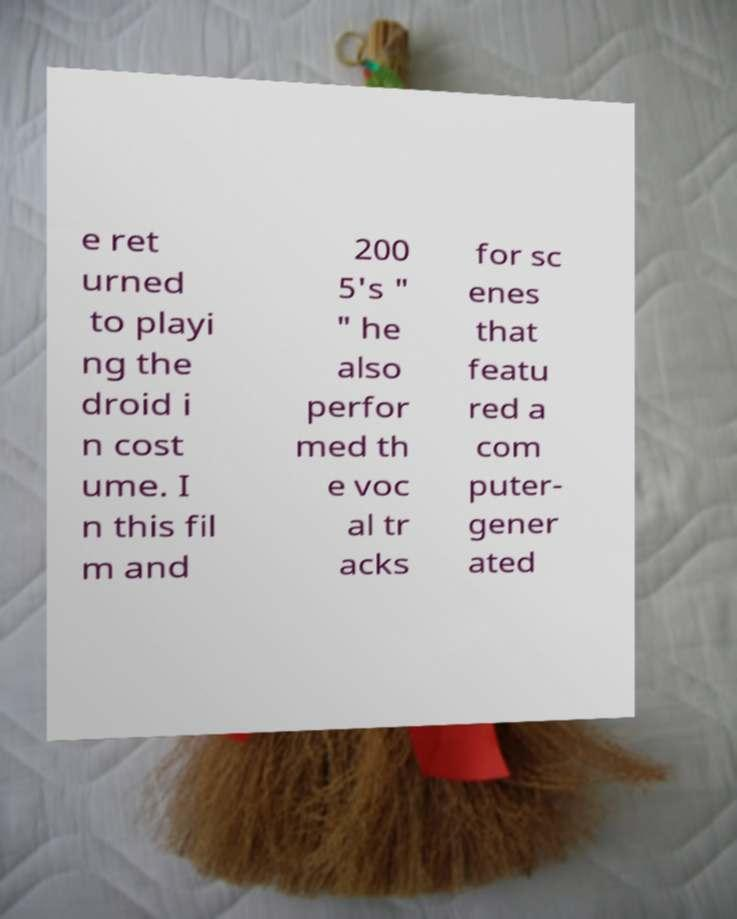Can you read and provide the text displayed in the image?This photo seems to have some interesting text. Can you extract and type it out for me? e ret urned to playi ng the droid i n cost ume. I n this fil m and 200 5's " " he also perfor med th e voc al tr acks for sc enes that featu red a com puter- gener ated 